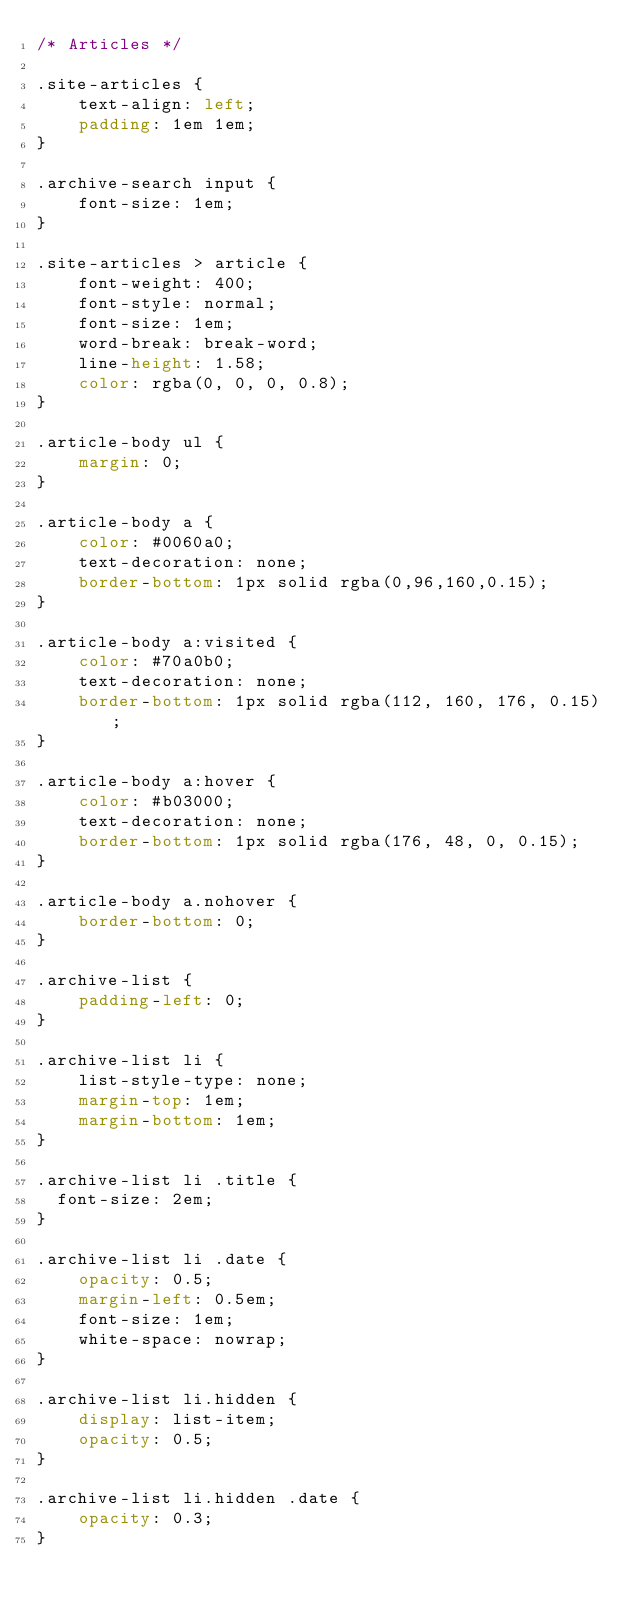<code> <loc_0><loc_0><loc_500><loc_500><_CSS_>/* Articles */

.site-articles {
    text-align: left;
    padding: 1em 1em;
}

.archive-search input {
    font-size: 1em;
}

.site-articles > article {
    font-weight: 400;
    font-style: normal;
    font-size: 1em;
    word-break: break-word;
    line-height: 1.58;
    color: rgba(0, 0, 0, 0.8);
}

.article-body ul {
    margin: 0;
}

.article-body a {
    color: #0060a0;
    text-decoration: none;
    border-bottom: 1px solid rgba(0,96,160,0.15);
}

.article-body a:visited {
    color: #70a0b0;
    text-decoration: none;
    border-bottom: 1px solid rgba(112, 160, 176, 0.15);
}

.article-body a:hover {
    color: #b03000;
    text-decoration: none;
    border-bottom: 1px solid rgba(176, 48, 0, 0.15);
}

.article-body a.nohover {
    border-bottom: 0;
}

.archive-list {
    padding-left: 0;
}

.archive-list li {
    list-style-type: none;
    margin-top: 1em;
    margin-bottom: 1em;
}

.archive-list li .title {
  font-size: 2em;
}

.archive-list li .date {
    opacity: 0.5;
    margin-left: 0.5em;
    font-size: 1em;
    white-space: nowrap;
}

.archive-list li.hidden {
    display: list-item;
    opacity: 0.5;
}

.archive-list li.hidden .date {
    opacity: 0.3;
}
</code> 